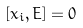Convert formula to latex. <formula><loc_0><loc_0><loc_500><loc_500>\left [ x _ { i } , E \right ] = 0</formula> 